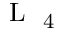<formula> <loc_0><loc_0><loc_500><loc_500>L _ { 4 }</formula> 